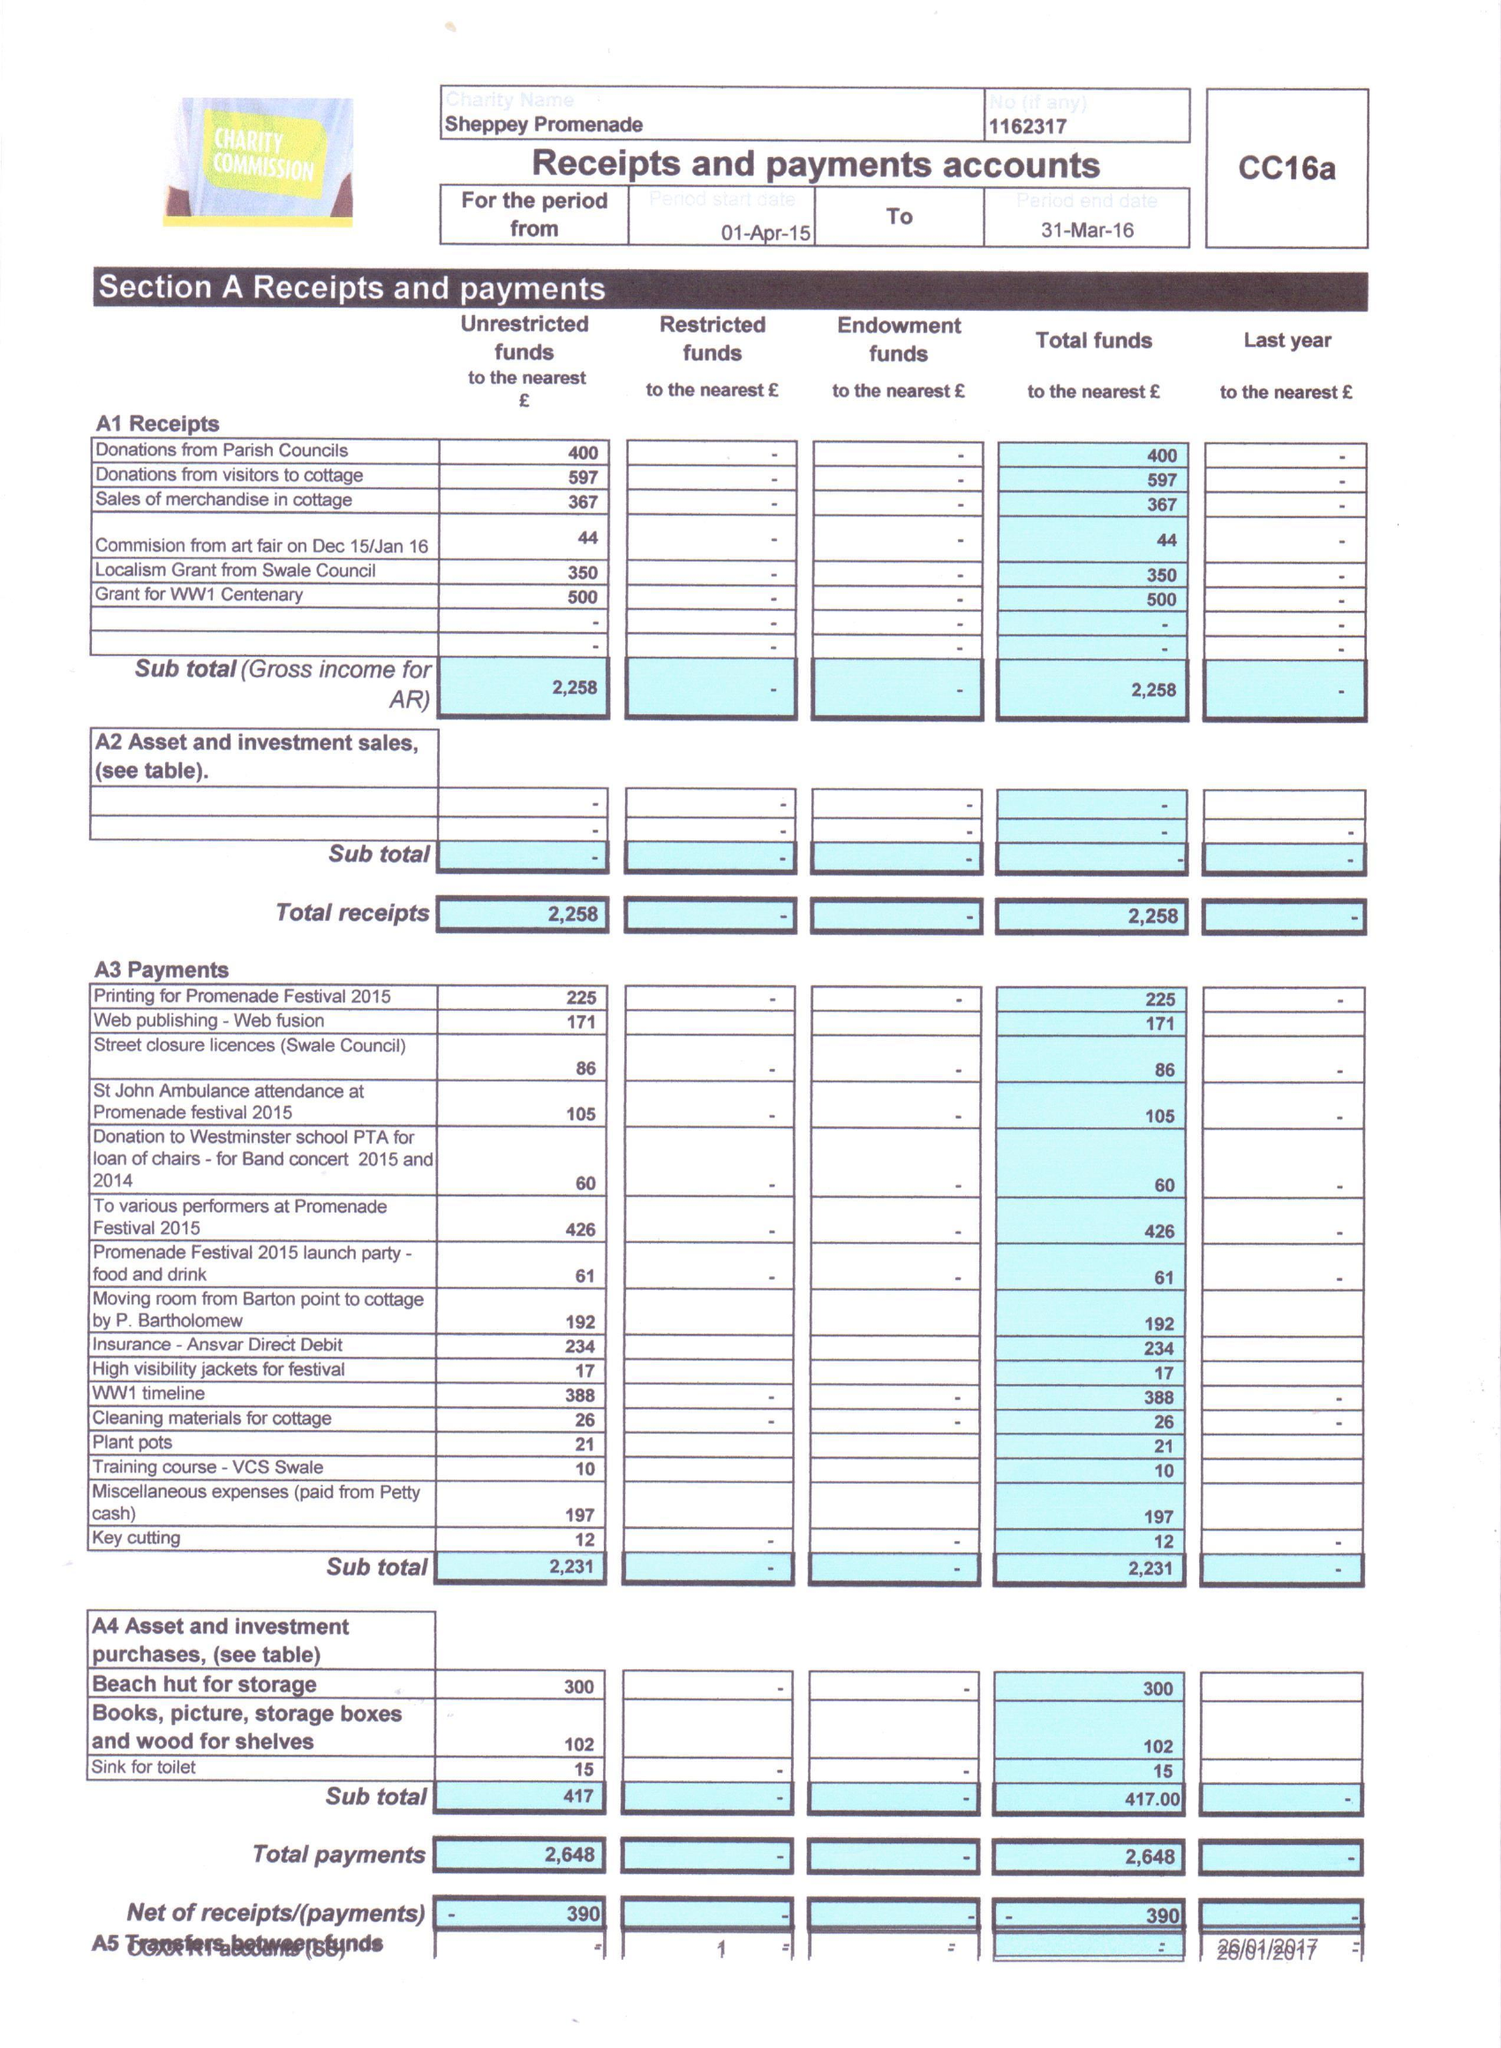What is the value for the report_date?
Answer the question using a single word or phrase. 2016-03-31 